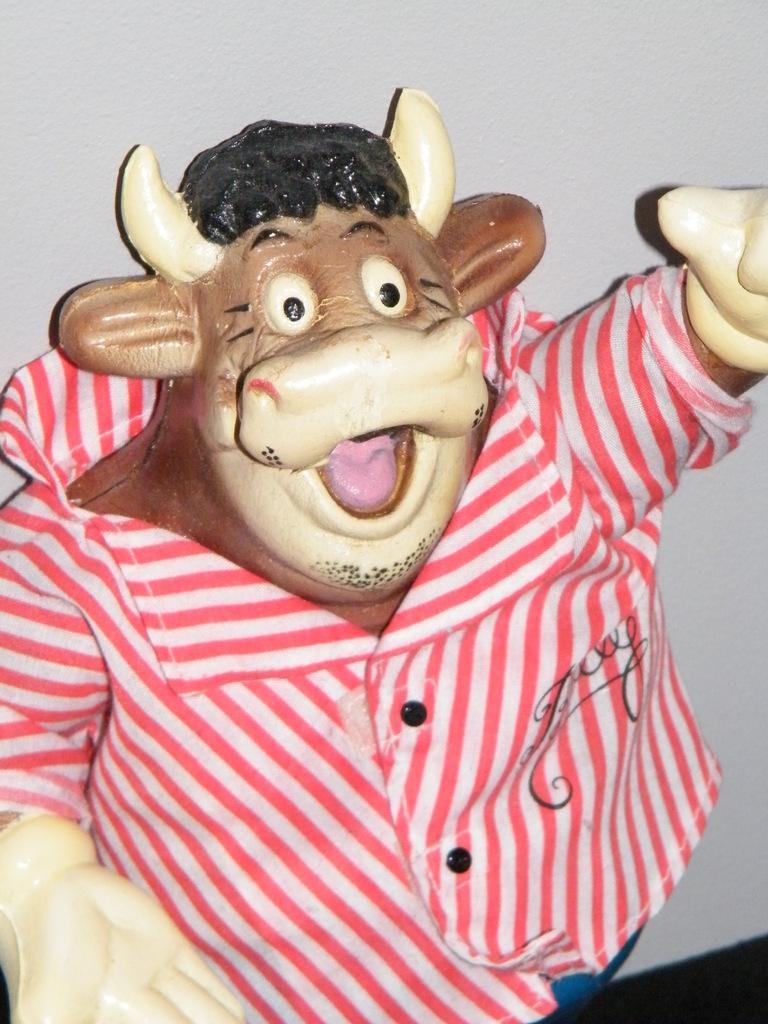Please provide a concise description of this image. In this image I can see a cow doll. On the doll I can see a shirt. Here I can see something written on it. In the background I can see a wall. 